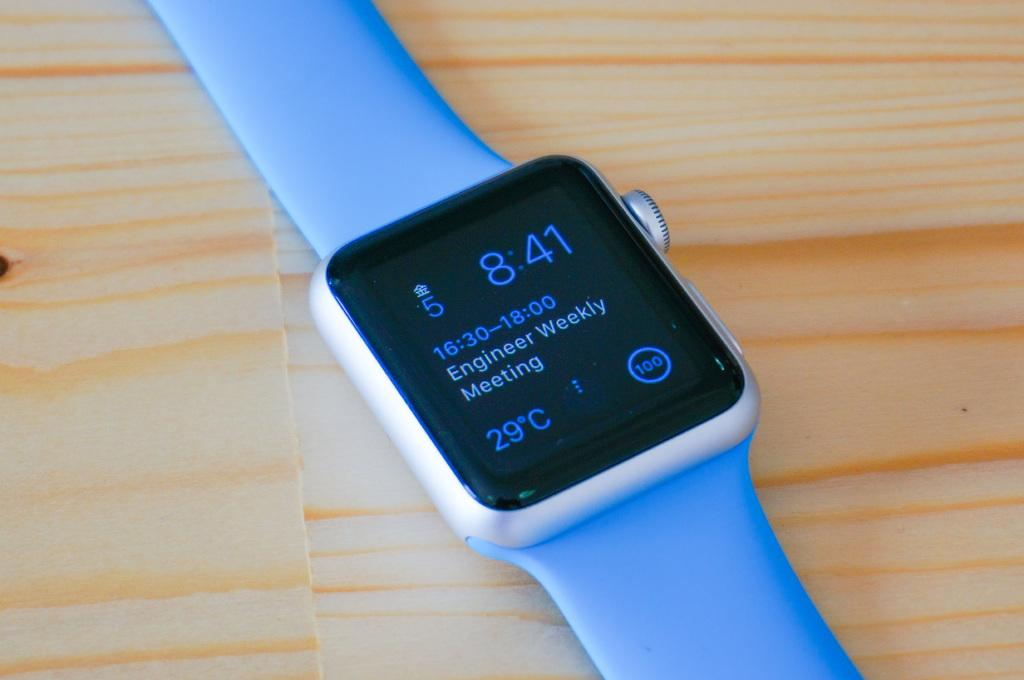<image>
Give a short and clear explanation of the subsequent image. Blue and black wrist watch that has the time at 8:41. 